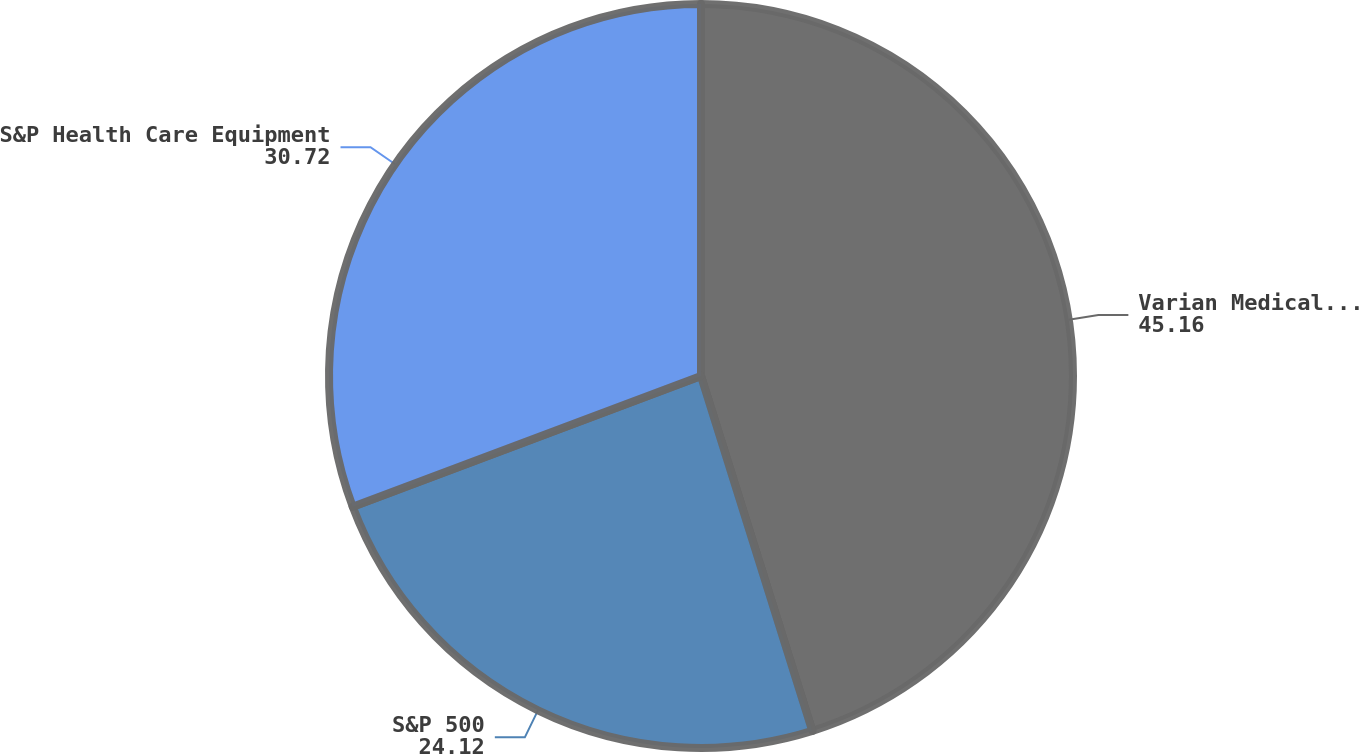Convert chart to OTSL. <chart><loc_0><loc_0><loc_500><loc_500><pie_chart><fcel>Varian Medical Systems Inc<fcel>S&P 500<fcel>S&P Health Care Equipment<nl><fcel>45.16%<fcel>24.12%<fcel>30.72%<nl></chart> 